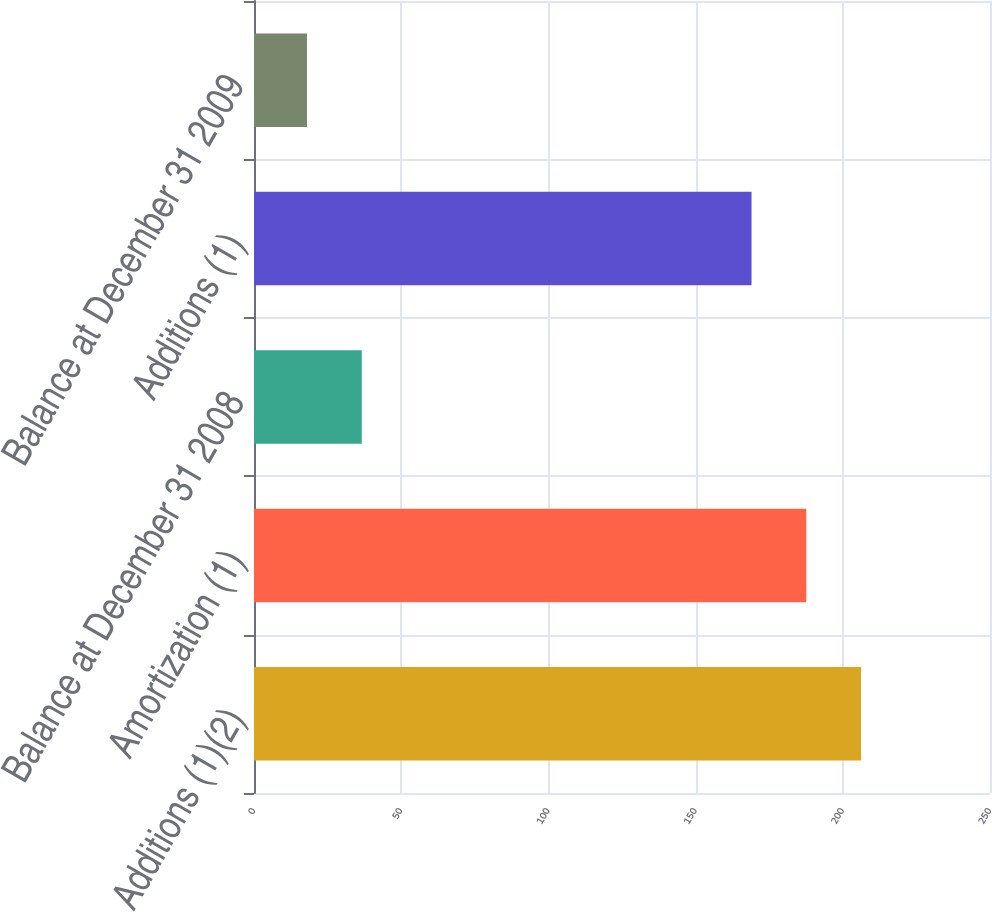Convert chart to OTSL. <chart><loc_0><loc_0><loc_500><loc_500><bar_chart><fcel>Additions (1)(2)<fcel>Amortization (1)<fcel>Balance at December 31 2008<fcel>Additions (1)<fcel>Balance at December 31 2009<nl><fcel>206.2<fcel>187.6<fcel>36.6<fcel>169<fcel>18<nl></chart> 